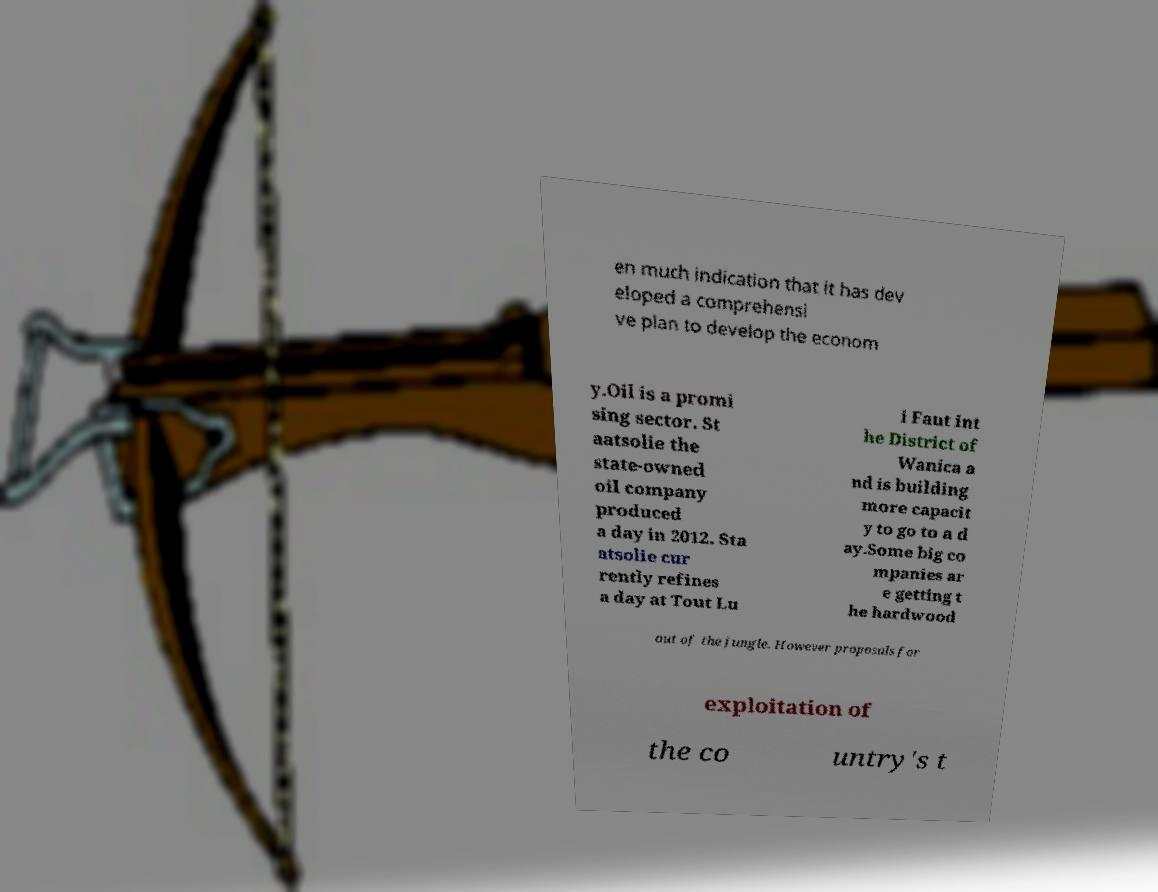I need the written content from this picture converted into text. Can you do that? en much indication that it has dev eloped a comprehensi ve plan to develop the econom y.Oil is a promi sing sector. St aatsolie the state-owned oil company produced a day in 2012. Sta atsolie cur rently refines a day at Tout Lu i Faut int he District of Wanica a nd is building more capacit y to go to a d ay.Some big co mpanies ar e getting t he hardwood out of the jungle. However proposals for exploitation of the co untry's t 